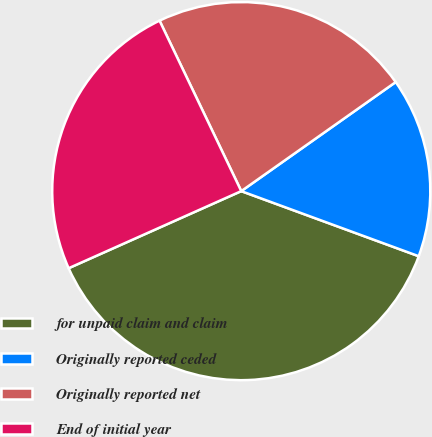Convert chart to OTSL. <chart><loc_0><loc_0><loc_500><loc_500><pie_chart><fcel>for unpaid claim and claim<fcel>Originally reported ceded<fcel>Originally reported net<fcel>End of initial year<nl><fcel>37.72%<fcel>15.38%<fcel>22.33%<fcel>24.57%<nl></chart> 